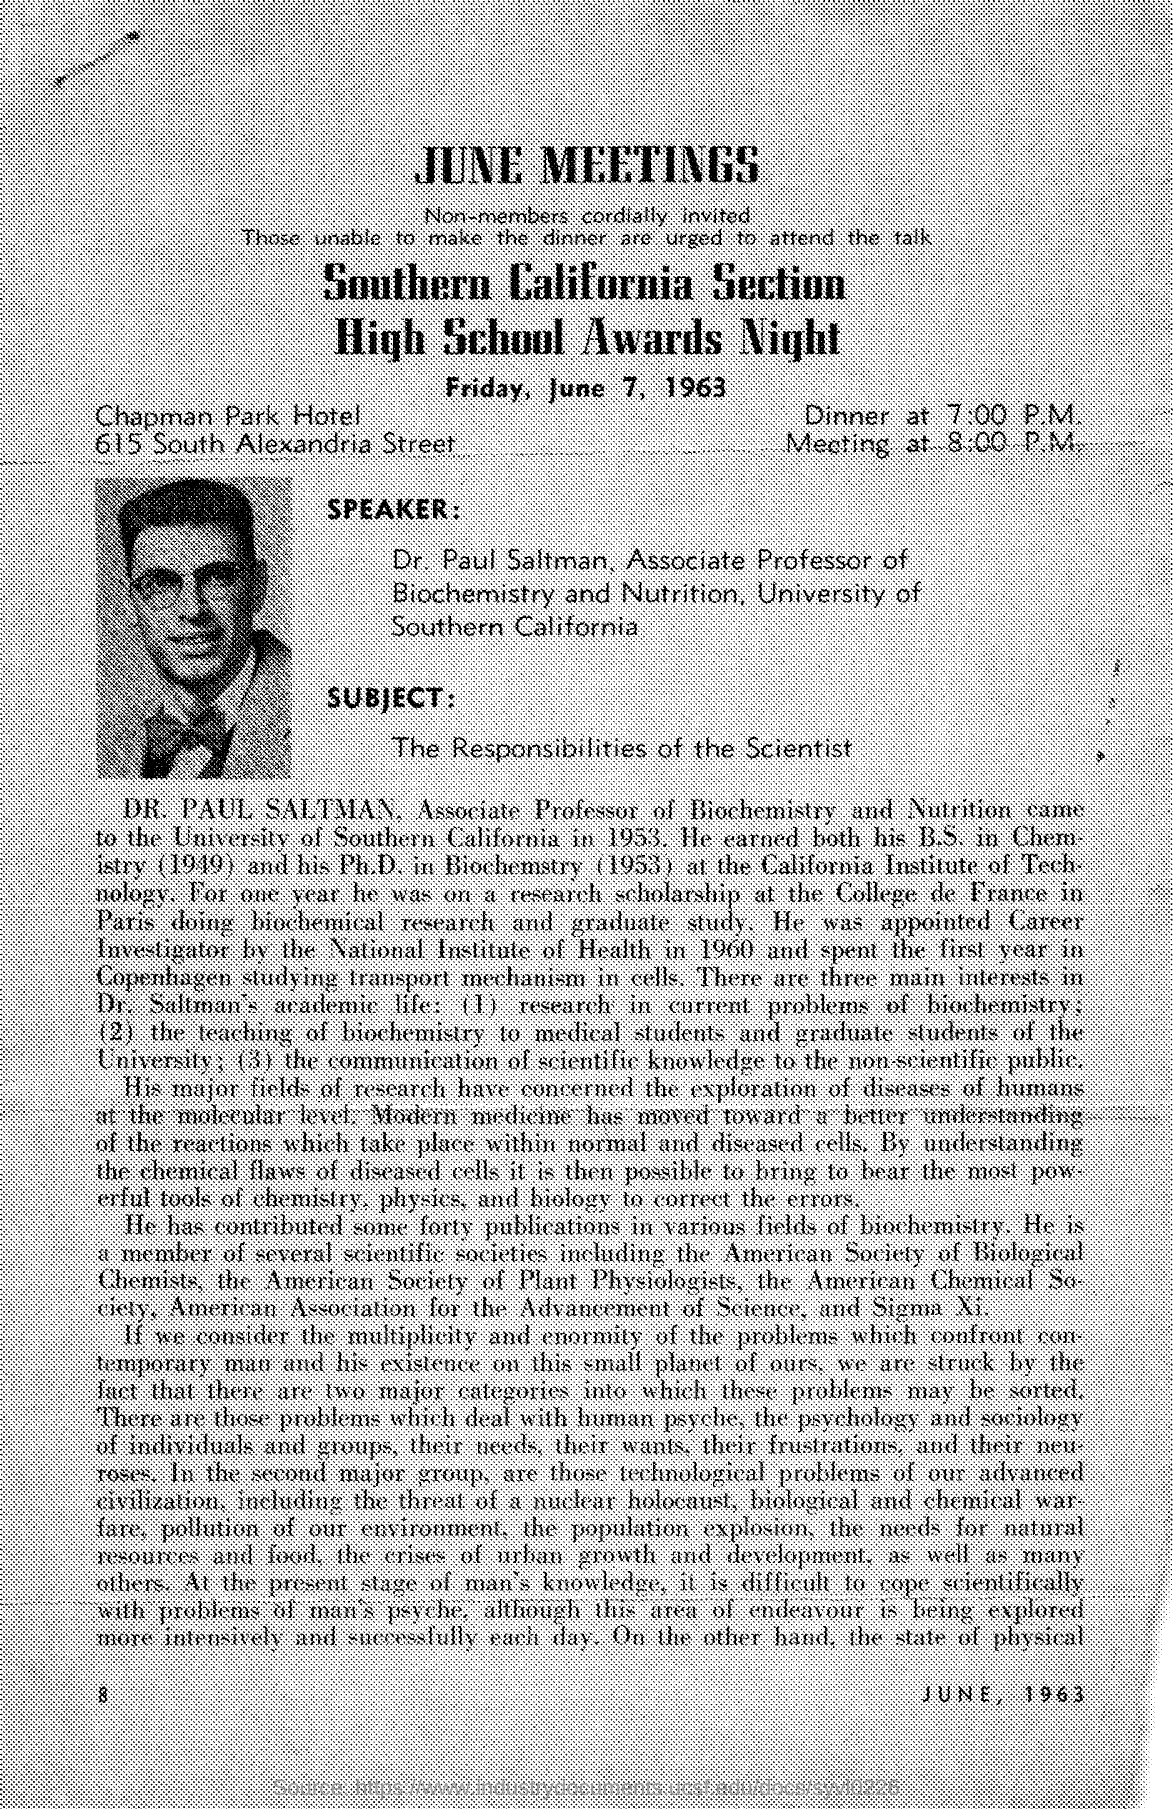Identify some key points in this picture. It is clear that Dr. Paul Saltman is a member of the University of Southern California. The date scheduled for the high school awards is Friday, June 7, 1963. The speaker mentioned in the given page is Dr. Paul Saltman. The name of the hotel mentioned in the given page is "Chapman Park Hotel. The time of dinner mentioned in the given form is 7:00 P.M. 